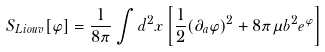Convert formula to latex. <formula><loc_0><loc_0><loc_500><loc_500>S _ { L i o u v } [ \varphi ] = { \frac { 1 } { 8 \pi } } \int d ^ { 2 } x \left [ { \frac { 1 } { 2 } } ( \partial _ { a } \varphi ) ^ { 2 } + 8 \pi \mu b ^ { 2 } e ^ { \varphi } \right ]</formula> 